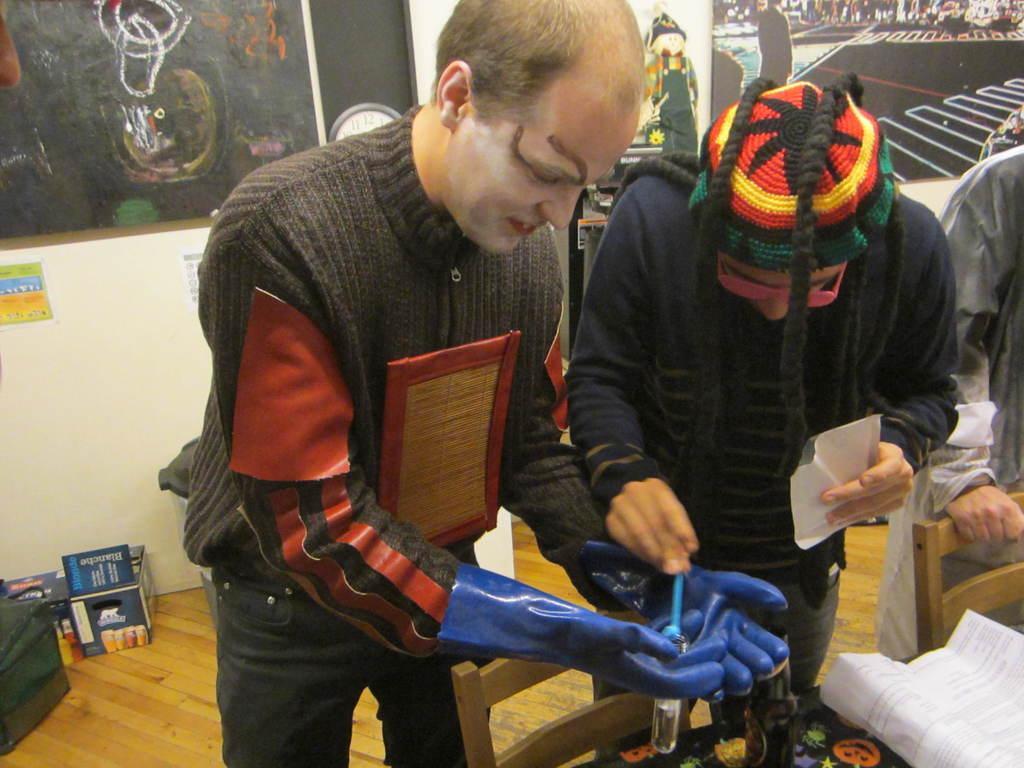Can you describe this image briefly? In this picture there is a man standing and holding the object and there is a man with blue sweatshirt is standing and holding the objects. On the right side of the image there is a person standing and there are chairs and there are objects on the table. On the left side of the image there are boxes and there is a bag and there is a board and there is a clock and poster on the wall and there is text on the posters. On the right side of the image there is a board and there is a toy and there are objects and there is a picture of group of people on the board. At the bottom there is a floor. 